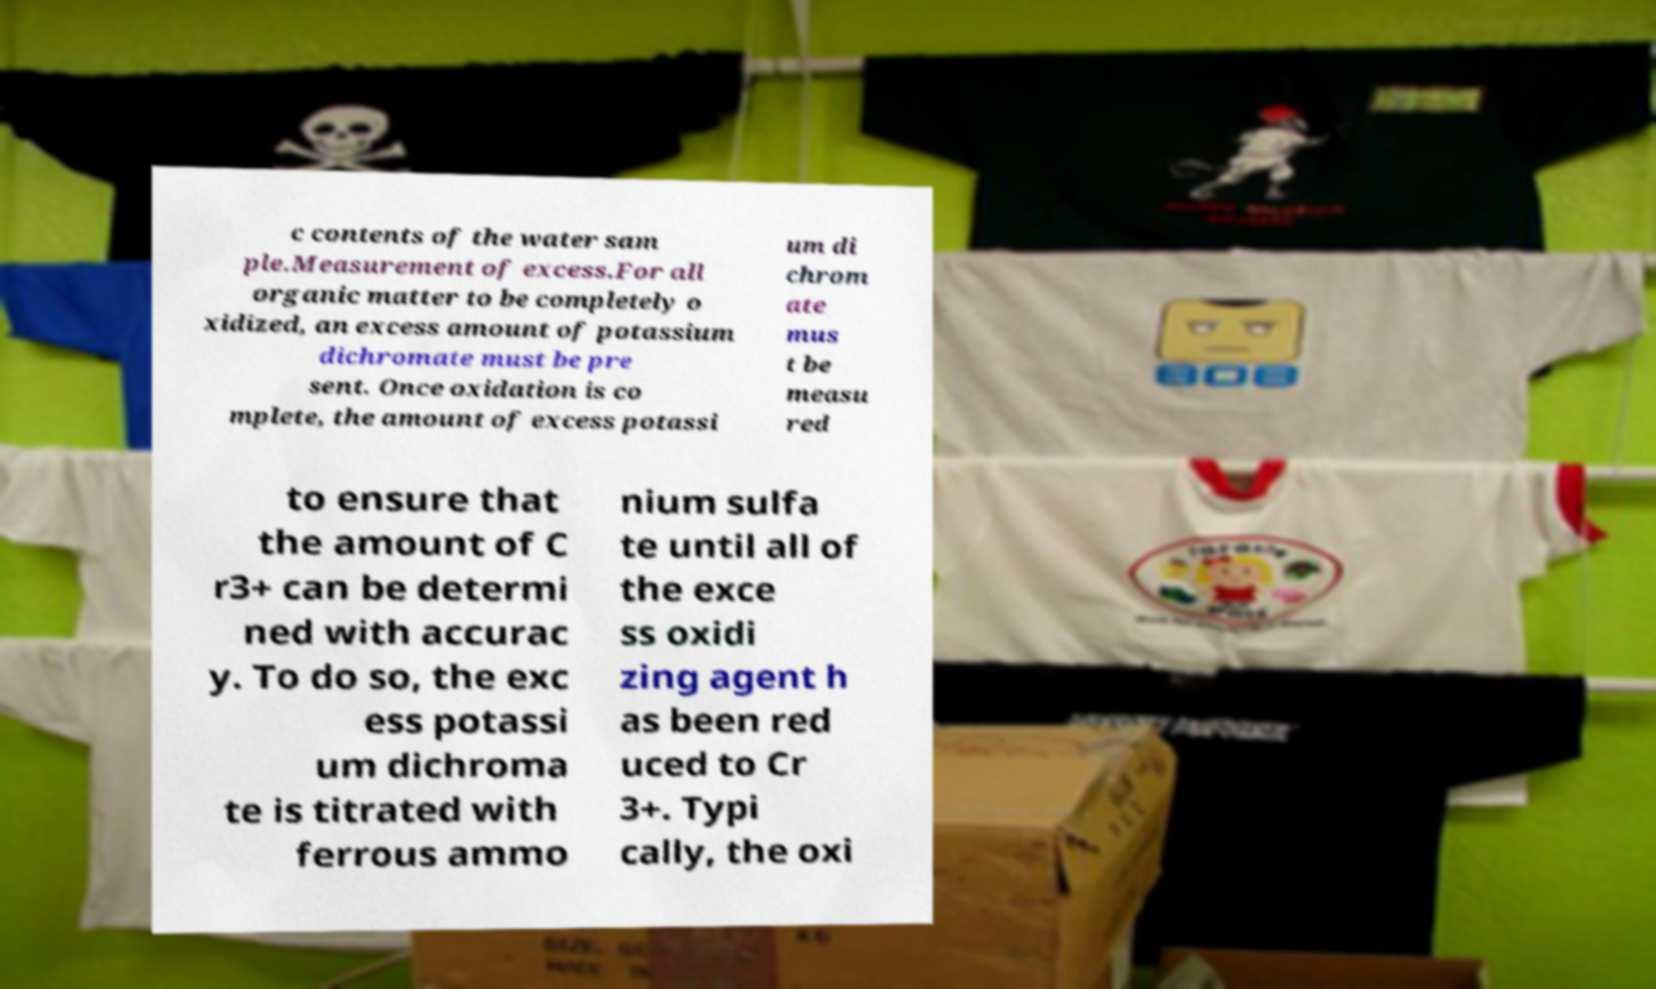Can you accurately transcribe the text from the provided image for me? c contents of the water sam ple.Measurement of excess.For all organic matter to be completely o xidized, an excess amount of potassium dichromate must be pre sent. Once oxidation is co mplete, the amount of excess potassi um di chrom ate mus t be measu red to ensure that the amount of C r3+ can be determi ned with accurac y. To do so, the exc ess potassi um dichroma te is titrated with ferrous ammo nium sulfa te until all of the exce ss oxidi zing agent h as been red uced to Cr 3+. Typi cally, the oxi 